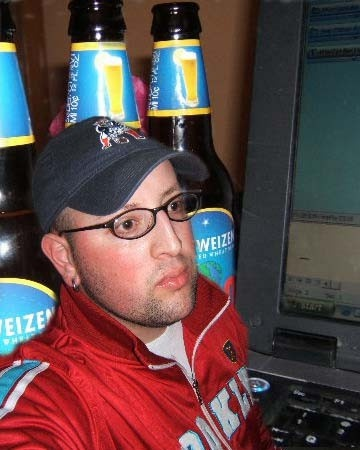Describe the objects in this image and their specific colors. I can see people in black, brown, and maroon tones, laptop in black, teal, gray, and purple tones, bottle in black, lightblue, teal, and ivory tones, bottle in black and lightblue tones, and bottle in black, ivory, lightblue, and khaki tones in this image. 